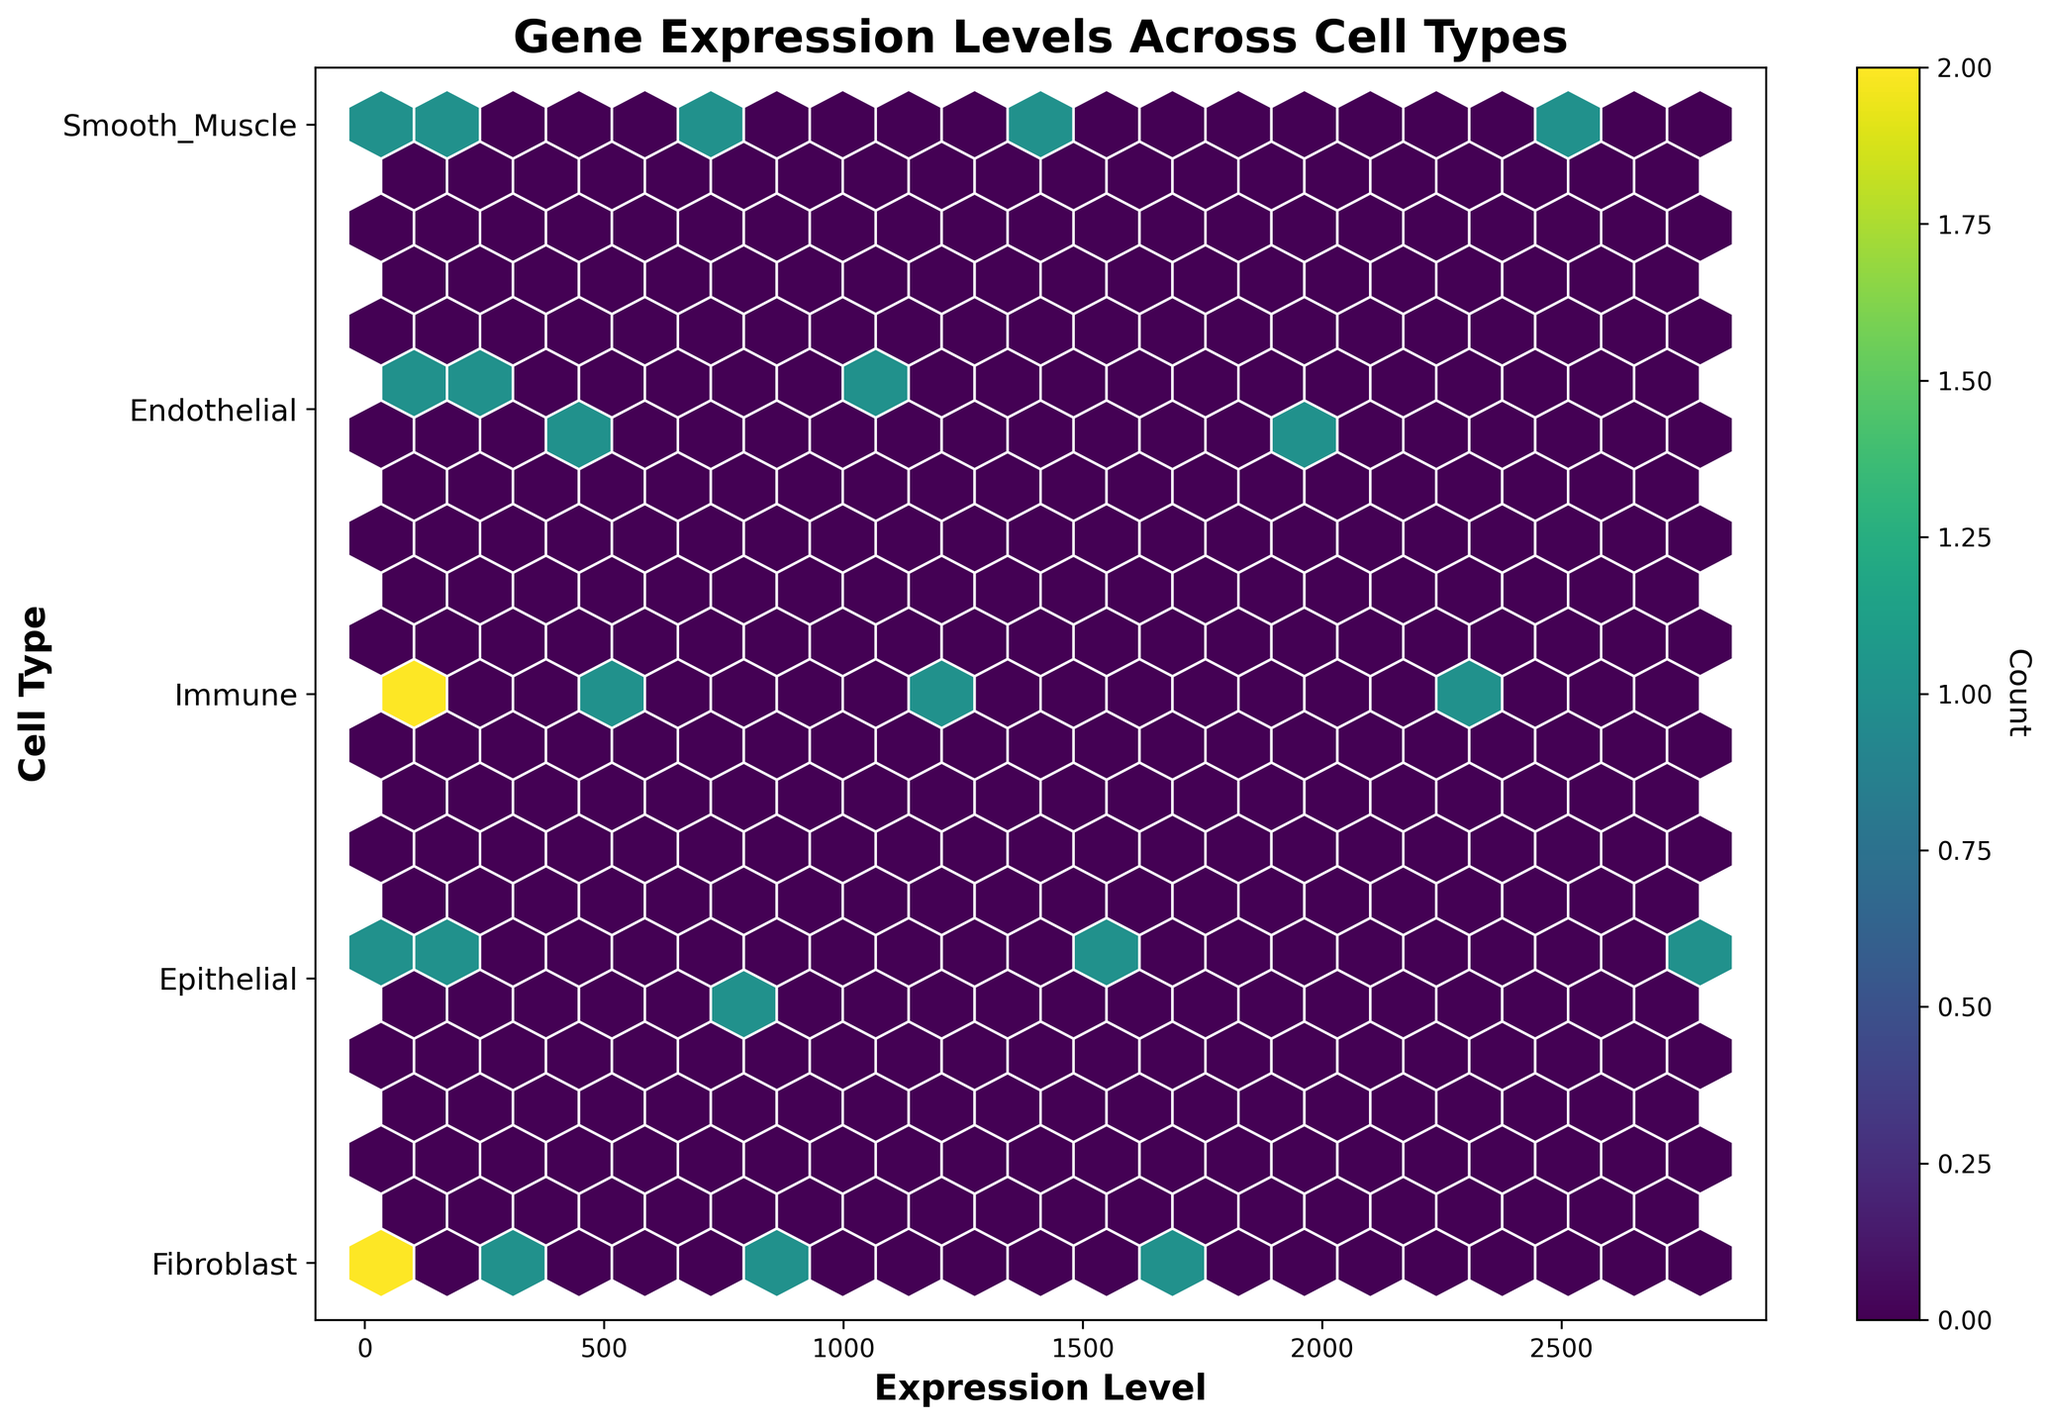What is the title of the plot? The title of the plot is displayed at the top of the figure. It reads “Gene Expression Levels Across Cell Types”.
Answer: Gene Expression Levels Across Cell Types What are the labels on the x-axis and y-axis? The labels on the x-axis and y-axis can be found below and beside the respective axes. The x-axis is labeled "Expression Level" and the y-axis is labeled "Cell Type".
Answer: Expression Level, Cell Type What color is used for the highest density of points in the hexbin plot? The highest density of points is represented by the color shown in the most intense areas of the hexbin plot. Looking at the color bar, the highest density color corresponds to a bright yellow.
Answer: Bright yellow How many cell types are represented in the plot? The y-axis has several distinct labels corresponding to each cell type. By counting these labels, we find that there are five distinct cell types: Fibroblast, Epithelial, Immune, Endothelial, and Smooth Muscle.
Answer: Five Which cell type has the highest expression level? By examining the hexagons that appear closest to the rightmost side of the plot (which corresponds to the highest values on the x-axis), we see that the cell type "Epithelial" has the highest expression level.
Answer: Epithelial What is the approximate range of expression levels for the Immune cell type? By locating the "Immune" category on the y-axis, we can assess the span of x-axis values that correspond to the hexagons aligned with this cell type. The expression levels for Immune range from around 100 to 2000.
Answer: 100 to 2000 Which cell type has the lowest expression level and what is that range? By examining the lowest values on the x-axis and corresponding y-axis labels, we find that the "Fibroblast" cell type has the lowest expression levels, ranging from approximately 30 to 2400.
Answer: Fibroblast, 30 to 2400 Which two cell types have overlapping expression levels around the value of 2000? By identifying the hexagons around the expression level of 2000 on the x-axis, and then looking at the corresponding y-axis labels, we see that "Fibroblast" and "Epithelial" have overlapping expression levels around 2000.
Answer: Fibroblast and Epithelial What is the count value for the highest density hexagon, as indicated by the colorbar? The colorbar provides a reference for interpreting the colors of the hexagons. The brightest color on the plot corresponds to the highest count value, which is approximately 4 as estimated from the colorbar's labels.
Answer: 4 